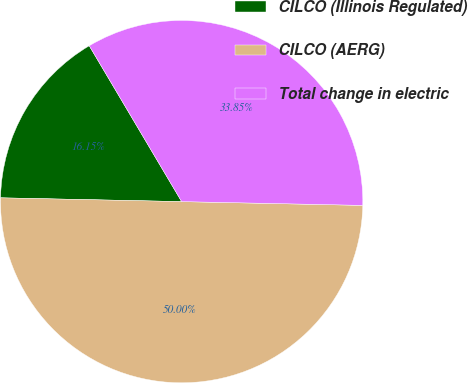Convert chart. <chart><loc_0><loc_0><loc_500><loc_500><pie_chart><fcel>CILCO (Illinois Regulated)<fcel>CILCO (AERG)<fcel>Total change in electric<nl><fcel>16.15%<fcel>50.0%<fcel>33.85%<nl></chart> 